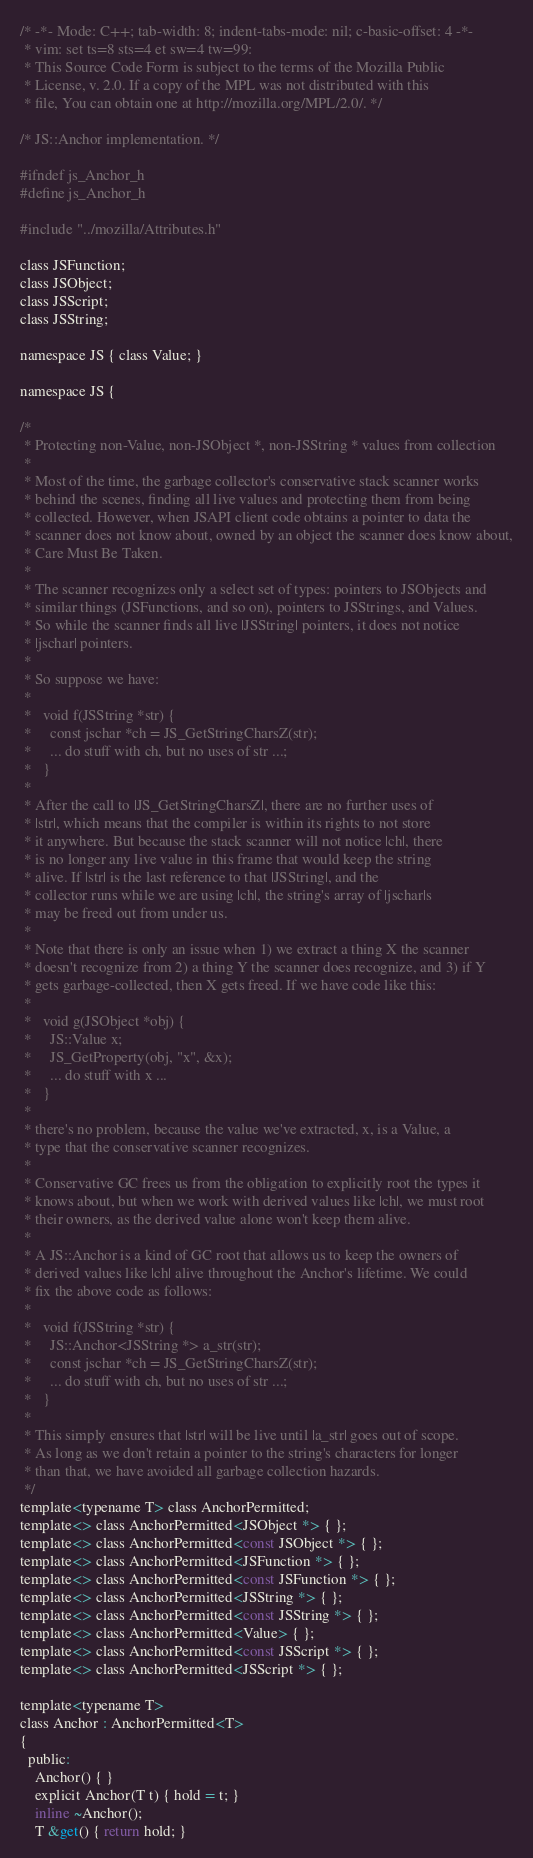<code> <loc_0><loc_0><loc_500><loc_500><_C_>/* -*- Mode: C++; tab-width: 8; indent-tabs-mode: nil; c-basic-offset: 4 -*-
 * vim: set ts=8 sts=4 et sw=4 tw=99:
 * This Source Code Form is subject to the terms of the Mozilla Public
 * License, v. 2.0. If a copy of the MPL was not distributed with this
 * file, You can obtain one at http://mozilla.org/MPL/2.0/. */

/* JS::Anchor implementation. */

#ifndef js_Anchor_h
#define js_Anchor_h

#include "../mozilla/Attributes.h"

class JSFunction;
class JSObject;
class JSScript;
class JSString;

namespace JS { class Value; }

namespace JS {

/*
 * Protecting non-Value, non-JSObject *, non-JSString * values from collection
 *
 * Most of the time, the garbage collector's conservative stack scanner works
 * behind the scenes, finding all live values and protecting them from being
 * collected. However, when JSAPI client code obtains a pointer to data the
 * scanner does not know about, owned by an object the scanner does know about,
 * Care Must Be Taken.
 *
 * The scanner recognizes only a select set of types: pointers to JSObjects and
 * similar things (JSFunctions, and so on), pointers to JSStrings, and Values.
 * So while the scanner finds all live |JSString| pointers, it does not notice
 * |jschar| pointers.
 *
 * So suppose we have:
 *
 *   void f(JSString *str) {
 *     const jschar *ch = JS_GetStringCharsZ(str);
 *     ... do stuff with ch, but no uses of str ...;
 *   }
 *
 * After the call to |JS_GetStringCharsZ|, there are no further uses of
 * |str|, which means that the compiler is within its rights to not store
 * it anywhere. But because the stack scanner will not notice |ch|, there
 * is no longer any live value in this frame that would keep the string
 * alive. If |str| is the last reference to that |JSString|, and the
 * collector runs while we are using |ch|, the string's array of |jschar|s
 * may be freed out from under us.
 *
 * Note that there is only an issue when 1) we extract a thing X the scanner
 * doesn't recognize from 2) a thing Y the scanner does recognize, and 3) if Y
 * gets garbage-collected, then X gets freed. If we have code like this:
 *
 *   void g(JSObject *obj) {
 *     JS::Value x;
 *     JS_GetProperty(obj, "x", &x);
 *     ... do stuff with x ...
 *   }
 *
 * there's no problem, because the value we've extracted, x, is a Value, a
 * type that the conservative scanner recognizes.
 *
 * Conservative GC frees us from the obligation to explicitly root the types it
 * knows about, but when we work with derived values like |ch|, we must root
 * their owners, as the derived value alone won't keep them alive.
 *
 * A JS::Anchor is a kind of GC root that allows us to keep the owners of
 * derived values like |ch| alive throughout the Anchor's lifetime. We could
 * fix the above code as follows:
 *
 *   void f(JSString *str) {
 *     JS::Anchor<JSString *> a_str(str);
 *     const jschar *ch = JS_GetStringCharsZ(str);
 *     ... do stuff with ch, but no uses of str ...;
 *   }
 *
 * This simply ensures that |str| will be live until |a_str| goes out of scope.
 * As long as we don't retain a pointer to the string's characters for longer
 * than that, we have avoided all garbage collection hazards.
 */
template<typename T> class AnchorPermitted;
template<> class AnchorPermitted<JSObject *> { };
template<> class AnchorPermitted<const JSObject *> { };
template<> class AnchorPermitted<JSFunction *> { };
template<> class AnchorPermitted<const JSFunction *> { };
template<> class AnchorPermitted<JSString *> { };
template<> class AnchorPermitted<const JSString *> { };
template<> class AnchorPermitted<Value> { };
template<> class AnchorPermitted<const JSScript *> { };
template<> class AnchorPermitted<JSScript *> { };

template<typename T>
class Anchor : AnchorPermitted<T>
{
  public:
    Anchor() { }
    explicit Anchor(T t) { hold = t; }
    inline ~Anchor();
    T &get() { return hold; }</code> 